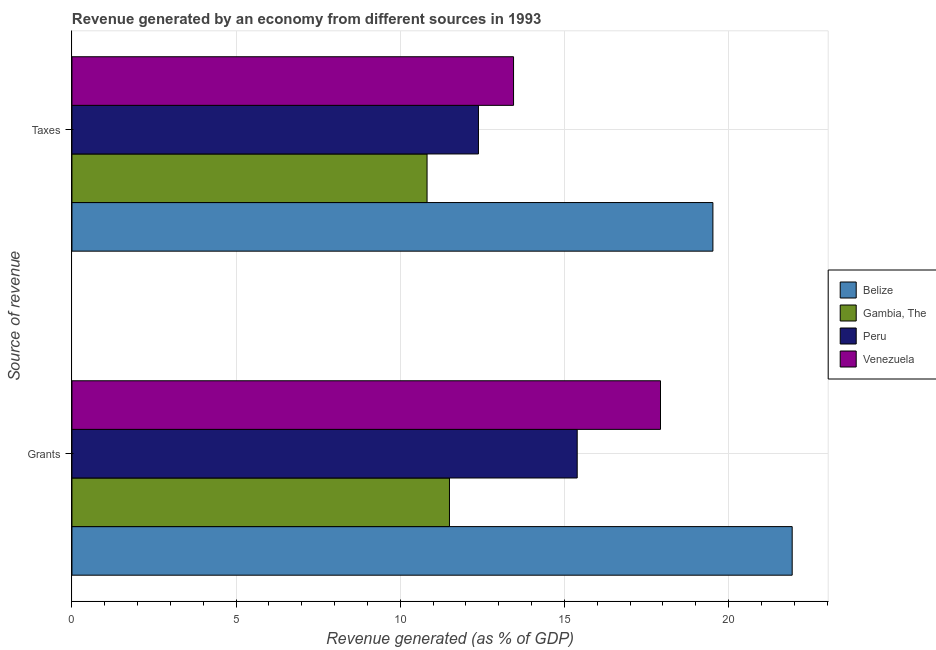How many groups of bars are there?
Make the answer very short. 2. How many bars are there on the 2nd tick from the top?
Your answer should be very brief. 4. What is the label of the 1st group of bars from the top?
Ensure brevity in your answer.  Taxes. What is the revenue generated by taxes in Venezuela?
Ensure brevity in your answer.  13.45. Across all countries, what is the maximum revenue generated by taxes?
Your response must be concise. 19.52. Across all countries, what is the minimum revenue generated by grants?
Offer a very short reply. 11.5. In which country was the revenue generated by grants maximum?
Your response must be concise. Belize. In which country was the revenue generated by taxes minimum?
Give a very brief answer. Gambia, The. What is the total revenue generated by grants in the graph?
Offer a very short reply. 66.75. What is the difference between the revenue generated by taxes in Venezuela and that in Belize?
Keep it short and to the point. -6.07. What is the difference between the revenue generated by grants in Belize and the revenue generated by taxes in Gambia, The?
Provide a short and direct response. 11.12. What is the average revenue generated by taxes per country?
Provide a short and direct response. 14.04. What is the difference between the revenue generated by taxes and revenue generated by grants in Peru?
Make the answer very short. -3.01. In how many countries, is the revenue generated by taxes greater than 12 %?
Your answer should be very brief. 3. What is the ratio of the revenue generated by grants in Peru to that in Gambia, The?
Keep it short and to the point. 1.34. In how many countries, is the revenue generated by taxes greater than the average revenue generated by taxes taken over all countries?
Make the answer very short. 1. What does the 3rd bar from the bottom in Taxes represents?
Your answer should be very brief. Peru. How many bars are there?
Offer a terse response. 8. Are all the bars in the graph horizontal?
Your response must be concise. Yes. What is the difference between two consecutive major ticks on the X-axis?
Your answer should be compact. 5. Are the values on the major ticks of X-axis written in scientific E-notation?
Give a very brief answer. No. Does the graph contain any zero values?
Your answer should be very brief. No. What is the title of the graph?
Keep it short and to the point. Revenue generated by an economy from different sources in 1993. What is the label or title of the X-axis?
Make the answer very short. Revenue generated (as % of GDP). What is the label or title of the Y-axis?
Your answer should be compact. Source of revenue. What is the Revenue generated (as % of GDP) in Belize in Grants?
Give a very brief answer. 21.94. What is the Revenue generated (as % of GDP) in Gambia, The in Grants?
Your answer should be very brief. 11.5. What is the Revenue generated (as % of GDP) of Peru in Grants?
Provide a succinct answer. 15.39. What is the Revenue generated (as % of GDP) of Venezuela in Grants?
Offer a very short reply. 17.93. What is the Revenue generated (as % of GDP) of Belize in Taxes?
Your answer should be compact. 19.52. What is the Revenue generated (as % of GDP) of Gambia, The in Taxes?
Offer a very short reply. 10.82. What is the Revenue generated (as % of GDP) in Peru in Taxes?
Your answer should be very brief. 12.38. What is the Revenue generated (as % of GDP) in Venezuela in Taxes?
Make the answer very short. 13.45. Across all Source of revenue, what is the maximum Revenue generated (as % of GDP) of Belize?
Make the answer very short. 21.94. Across all Source of revenue, what is the maximum Revenue generated (as % of GDP) of Gambia, The?
Make the answer very short. 11.5. Across all Source of revenue, what is the maximum Revenue generated (as % of GDP) of Peru?
Offer a terse response. 15.39. Across all Source of revenue, what is the maximum Revenue generated (as % of GDP) in Venezuela?
Offer a terse response. 17.93. Across all Source of revenue, what is the minimum Revenue generated (as % of GDP) of Belize?
Your answer should be compact. 19.52. Across all Source of revenue, what is the minimum Revenue generated (as % of GDP) of Gambia, The?
Offer a terse response. 10.82. Across all Source of revenue, what is the minimum Revenue generated (as % of GDP) in Peru?
Offer a very short reply. 12.38. Across all Source of revenue, what is the minimum Revenue generated (as % of GDP) in Venezuela?
Provide a short and direct response. 13.45. What is the total Revenue generated (as % of GDP) in Belize in the graph?
Offer a terse response. 41.46. What is the total Revenue generated (as % of GDP) in Gambia, The in the graph?
Make the answer very short. 22.31. What is the total Revenue generated (as % of GDP) of Peru in the graph?
Offer a terse response. 27.77. What is the total Revenue generated (as % of GDP) of Venezuela in the graph?
Provide a short and direct response. 31.38. What is the difference between the Revenue generated (as % of GDP) in Belize in Grants and that in Taxes?
Provide a short and direct response. 2.41. What is the difference between the Revenue generated (as % of GDP) in Gambia, The in Grants and that in Taxes?
Ensure brevity in your answer.  0.68. What is the difference between the Revenue generated (as % of GDP) in Peru in Grants and that in Taxes?
Provide a succinct answer. 3.01. What is the difference between the Revenue generated (as % of GDP) of Venezuela in Grants and that in Taxes?
Ensure brevity in your answer.  4.48. What is the difference between the Revenue generated (as % of GDP) of Belize in Grants and the Revenue generated (as % of GDP) of Gambia, The in Taxes?
Your response must be concise. 11.12. What is the difference between the Revenue generated (as % of GDP) of Belize in Grants and the Revenue generated (as % of GDP) of Peru in Taxes?
Your response must be concise. 9.56. What is the difference between the Revenue generated (as % of GDP) in Belize in Grants and the Revenue generated (as % of GDP) in Venezuela in Taxes?
Offer a terse response. 8.49. What is the difference between the Revenue generated (as % of GDP) of Gambia, The in Grants and the Revenue generated (as % of GDP) of Peru in Taxes?
Give a very brief answer. -0.88. What is the difference between the Revenue generated (as % of GDP) of Gambia, The in Grants and the Revenue generated (as % of GDP) of Venezuela in Taxes?
Offer a very short reply. -1.95. What is the difference between the Revenue generated (as % of GDP) in Peru in Grants and the Revenue generated (as % of GDP) in Venezuela in Taxes?
Give a very brief answer. 1.94. What is the average Revenue generated (as % of GDP) in Belize per Source of revenue?
Offer a very short reply. 20.73. What is the average Revenue generated (as % of GDP) of Gambia, The per Source of revenue?
Your answer should be very brief. 11.16. What is the average Revenue generated (as % of GDP) in Peru per Source of revenue?
Your answer should be compact. 13.88. What is the average Revenue generated (as % of GDP) of Venezuela per Source of revenue?
Keep it short and to the point. 15.69. What is the difference between the Revenue generated (as % of GDP) in Belize and Revenue generated (as % of GDP) in Gambia, The in Grants?
Ensure brevity in your answer.  10.44. What is the difference between the Revenue generated (as % of GDP) of Belize and Revenue generated (as % of GDP) of Peru in Grants?
Keep it short and to the point. 6.55. What is the difference between the Revenue generated (as % of GDP) of Belize and Revenue generated (as % of GDP) of Venezuela in Grants?
Provide a succinct answer. 4.01. What is the difference between the Revenue generated (as % of GDP) of Gambia, The and Revenue generated (as % of GDP) of Peru in Grants?
Ensure brevity in your answer.  -3.89. What is the difference between the Revenue generated (as % of GDP) in Gambia, The and Revenue generated (as % of GDP) in Venezuela in Grants?
Ensure brevity in your answer.  -6.43. What is the difference between the Revenue generated (as % of GDP) in Peru and Revenue generated (as % of GDP) in Venezuela in Grants?
Provide a succinct answer. -2.54. What is the difference between the Revenue generated (as % of GDP) of Belize and Revenue generated (as % of GDP) of Gambia, The in Taxes?
Your answer should be very brief. 8.71. What is the difference between the Revenue generated (as % of GDP) of Belize and Revenue generated (as % of GDP) of Peru in Taxes?
Your response must be concise. 7.14. What is the difference between the Revenue generated (as % of GDP) of Belize and Revenue generated (as % of GDP) of Venezuela in Taxes?
Offer a terse response. 6.07. What is the difference between the Revenue generated (as % of GDP) in Gambia, The and Revenue generated (as % of GDP) in Peru in Taxes?
Offer a very short reply. -1.57. What is the difference between the Revenue generated (as % of GDP) of Gambia, The and Revenue generated (as % of GDP) of Venezuela in Taxes?
Offer a very short reply. -2.63. What is the difference between the Revenue generated (as % of GDP) of Peru and Revenue generated (as % of GDP) of Venezuela in Taxes?
Keep it short and to the point. -1.07. What is the ratio of the Revenue generated (as % of GDP) of Belize in Grants to that in Taxes?
Your response must be concise. 1.12. What is the ratio of the Revenue generated (as % of GDP) of Gambia, The in Grants to that in Taxes?
Your answer should be very brief. 1.06. What is the ratio of the Revenue generated (as % of GDP) in Peru in Grants to that in Taxes?
Keep it short and to the point. 1.24. What is the ratio of the Revenue generated (as % of GDP) in Venezuela in Grants to that in Taxes?
Make the answer very short. 1.33. What is the difference between the highest and the second highest Revenue generated (as % of GDP) of Belize?
Your answer should be very brief. 2.41. What is the difference between the highest and the second highest Revenue generated (as % of GDP) in Gambia, The?
Your response must be concise. 0.68. What is the difference between the highest and the second highest Revenue generated (as % of GDP) in Peru?
Offer a terse response. 3.01. What is the difference between the highest and the second highest Revenue generated (as % of GDP) in Venezuela?
Offer a very short reply. 4.48. What is the difference between the highest and the lowest Revenue generated (as % of GDP) of Belize?
Offer a terse response. 2.41. What is the difference between the highest and the lowest Revenue generated (as % of GDP) in Gambia, The?
Keep it short and to the point. 0.68. What is the difference between the highest and the lowest Revenue generated (as % of GDP) in Peru?
Provide a short and direct response. 3.01. What is the difference between the highest and the lowest Revenue generated (as % of GDP) in Venezuela?
Ensure brevity in your answer.  4.48. 